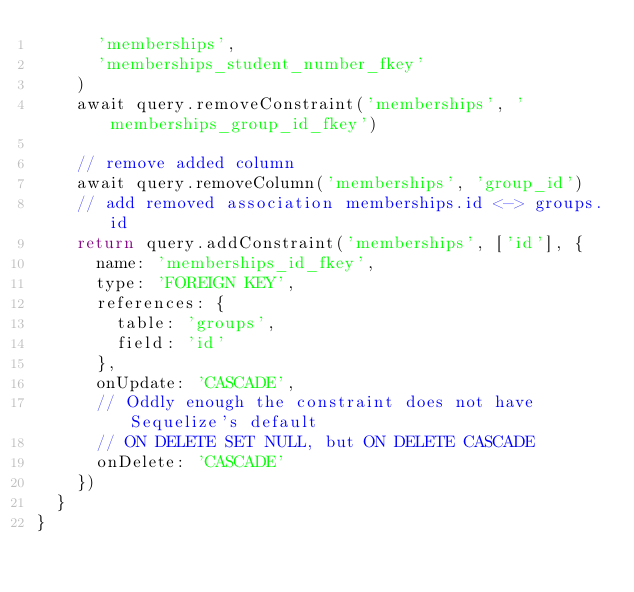Convert code to text. <code><loc_0><loc_0><loc_500><loc_500><_JavaScript_>      'memberships',
      'memberships_student_number_fkey'
    )
    await query.removeConstraint('memberships', 'memberships_group_id_fkey')

    // remove added column
    await query.removeColumn('memberships', 'group_id')
    // add removed association memberships.id <-> groups.id
    return query.addConstraint('memberships', ['id'], {
      name: 'memberships_id_fkey',
      type: 'FOREIGN KEY',
      references: {
        table: 'groups',
        field: 'id'
      },
      onUpdate: 'CASCADE',
      // Oddly enough the constraint does not have Sequelize's default
      // ON DELETE SET NULL, but ON DELETE CASCADE
      onDelete: 'CASCADE'
    })
  }
}
</code> 